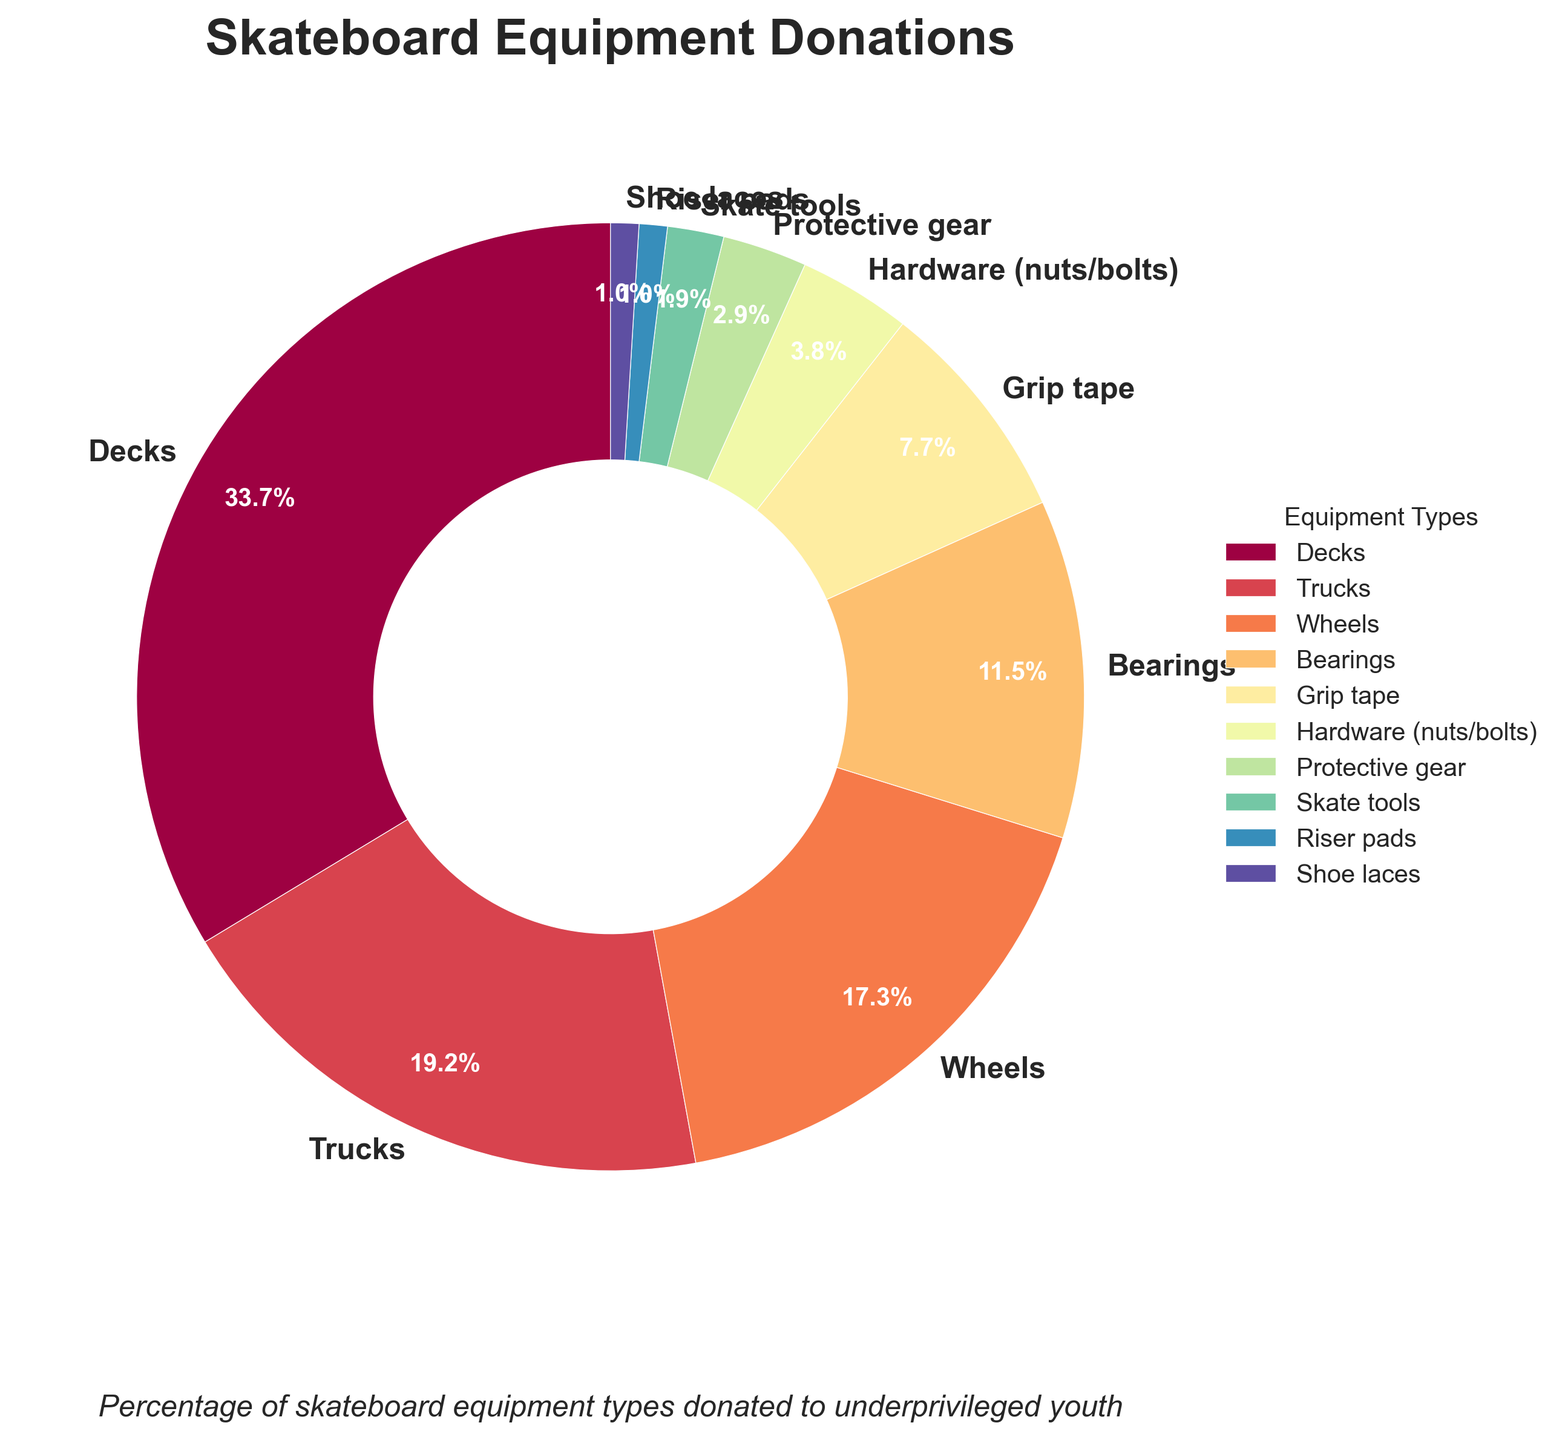What percentage of the skateboard equipment donated are Decks? Upon observing the pie chart, it is visible that Decks constitute 35% of the total skateboard equipment donated.
Answer: 35% Which equipment type has the smallest share of donations? The pie chart shows that Riser pads and Shoe laces each constitute only 1% of the total donations, which is the smallest share.
Answer: Riser pads, Shoe laces What is the combined percentage of Trucks and Wheels donated? From the chart, the percentage of Trucks donated is 20%, and Wheels is 18%. Adding these together, 20% + 18% = 38%.
Answer: 38% How much higher is the percentage of Decks donated compared to Protective gear? Decks constitute 35% and Protective gear 3%. The difference is 35% - 3% = 32%.
Answer: 32% Which equipment types together make up more than half of the total donations? By examining the chart, Decks (35%), Trucks (20%), and Wheels (18%) collectively account for 35% + 20% + 18% = 73%, which is more than half.
Answer: Decks, Trucks, Wheels How many equipment types have at least a 10% share of the total donations? The pie chart shows that Decks (35%), Trucks (20%), Wheels (18%), and Bearings (12%) each have at least 10%. That's a total of 4 equipment types.
Answer: 4 By how much does the percentage of Grip tape donations exceed that of Skate tools? Grip tape has 8% of the donations, while Skate tools have 2%. The difference is 8% - 2% = 6%.
Answer: 6% What is the combined percentage of the three smallest equipment types in the donations? The smallest equipment types are Riser pads (1%), Shoe laces (1%), and Skate tools (2%). Adding these together, 1% + 1% + 2% = 4%.
Answer: 4% Are the Bearings percentage donated closer to the Decks or to the Trucks percentage? Bearings have 12%, Decks have 35%, and Trucks have 20%. The differences are as follows:
Answer: Bearings are closer to the Trucks than to the Decks. (20%-12% = 8% vs. 35%-12% = 23%) Which equipment type has nearly half the percentage of the Decks? Bearings are at 12%, which is nearly half of the Decks' 35% (since 12% x 2 = 24% is close to 35% / 2 = 17.5%).
Answer: Bearings 